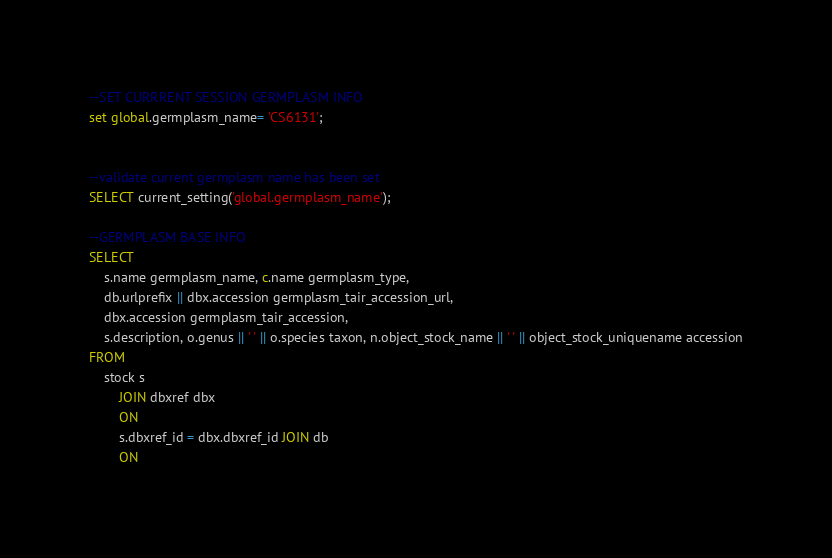Convert code to text. <code><loc_0><loc_0><loc_500><loc_500><_SQL_>--SET CURRRENT SESSION GERMPLASM INFO
set global.germplasm_name= 'CS6131';


--validate current germplasm name has been set
SELECT current_setting('global.germplasm_name'); 

--GERMPLASM BASE INFO 
SELECT
	s.name germplasm_name, c.name germplasm_type,
	db.urlprefix || dbx.accession germplasm_tair_accession_url,
	dbx.accession germplasm_tair_accession,
	s.description, o.genus || ' ' || o.species taxon, n.object_stock_name || ' ' || object_stock_uniquename accession
FROM
	stock s
		JOIN dbxref dbx
		ON
		s.dbxref_id = dbx.dbxref_id JOIN db
		ON</code> 